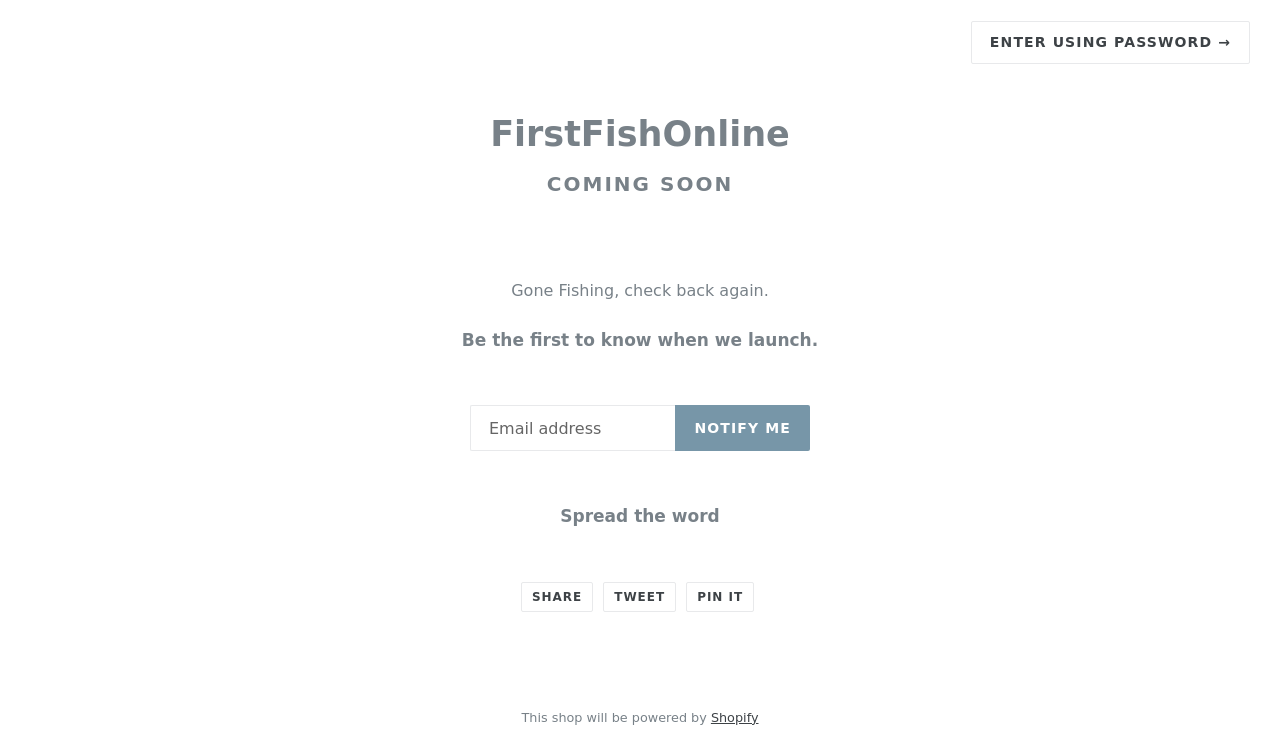What marketing benefits does the phrase 'Spread the word' add to this page? Including 'Spread the word' with social sharing options directly engages visitors, prompting them to share the site on their social networks. This not only broadens the potential reach and visibility of FirstFishOnline by utilizing the networks of its visitors but also adds a community and grassroots feel to the marketing efforts, which can enhance user engagement and loyalty. 